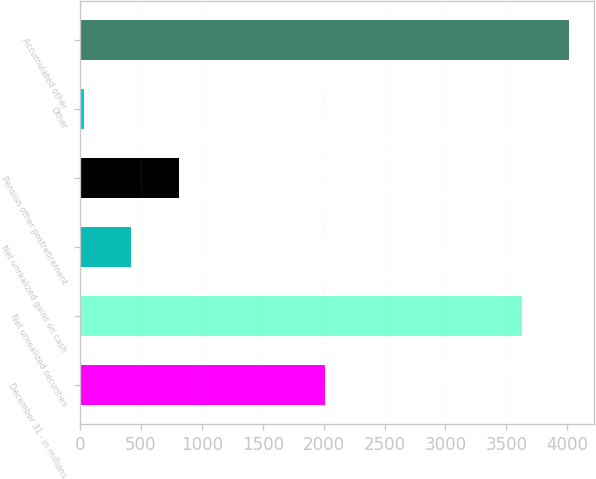Convert chart to OTSL. <chart><loc_0><loc_0><loc_500><loc_500><bar_chart><fcel>December 31 - in millions<fcel>Net unrealized securities<fcel>Net unrealized gains on cash<fcel>Pension other postretirement<fcel>Other<fcel>Accumulated other<nl><fcel>2008<fcel>3626<fcel>421.9<fcel>813.8<fcel>30<fcel>4017.9<nl></chart> 